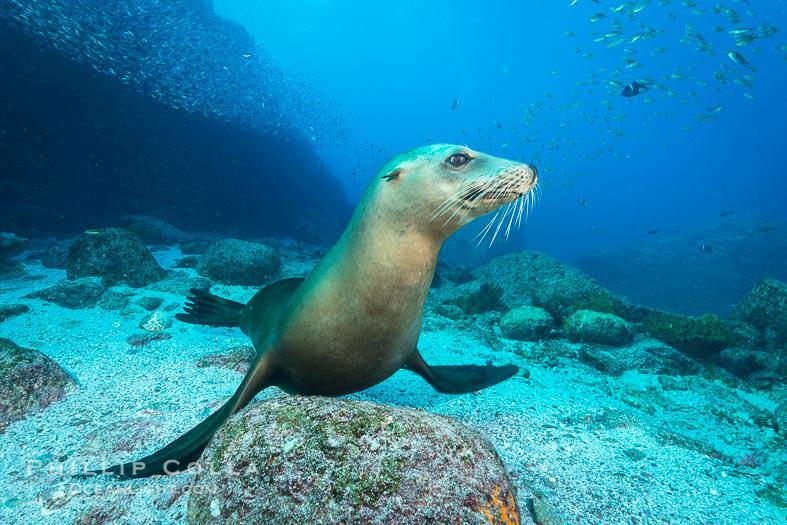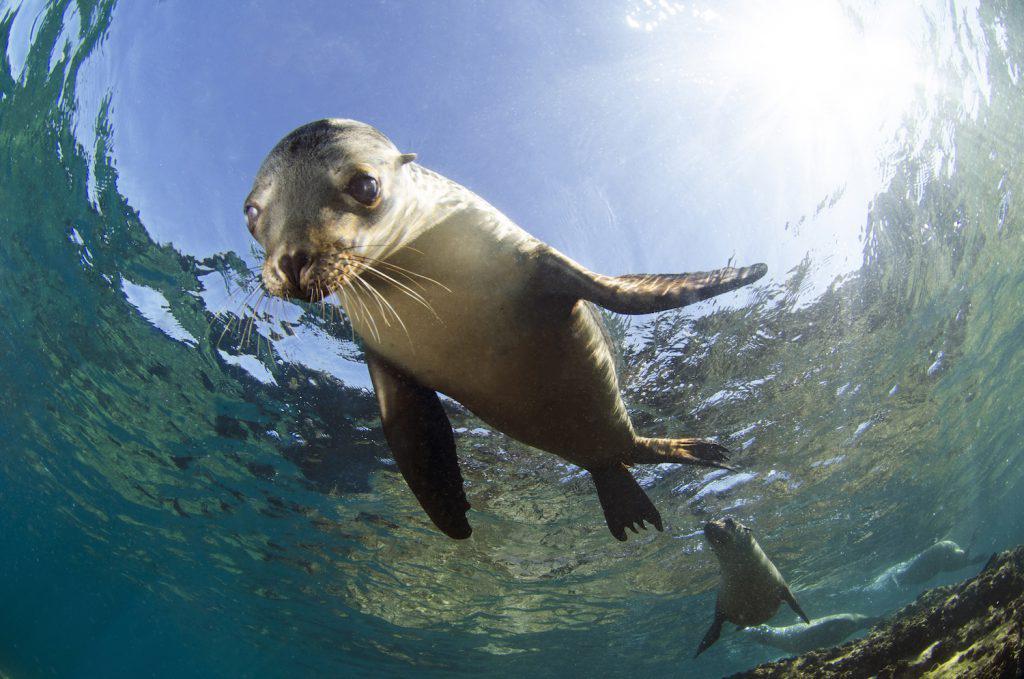The first image is the image on the left, the second image is the image on the right. Given the left and right images, does the statement "A diver is swimming near a sea animal." hold true? Answer yes or no. No. The first image is the image on the left, the second image is the image on the right. For the images shown, is this caption "An image of an otter underwater includes a scuba diver." true? Answer yes or no. No. 